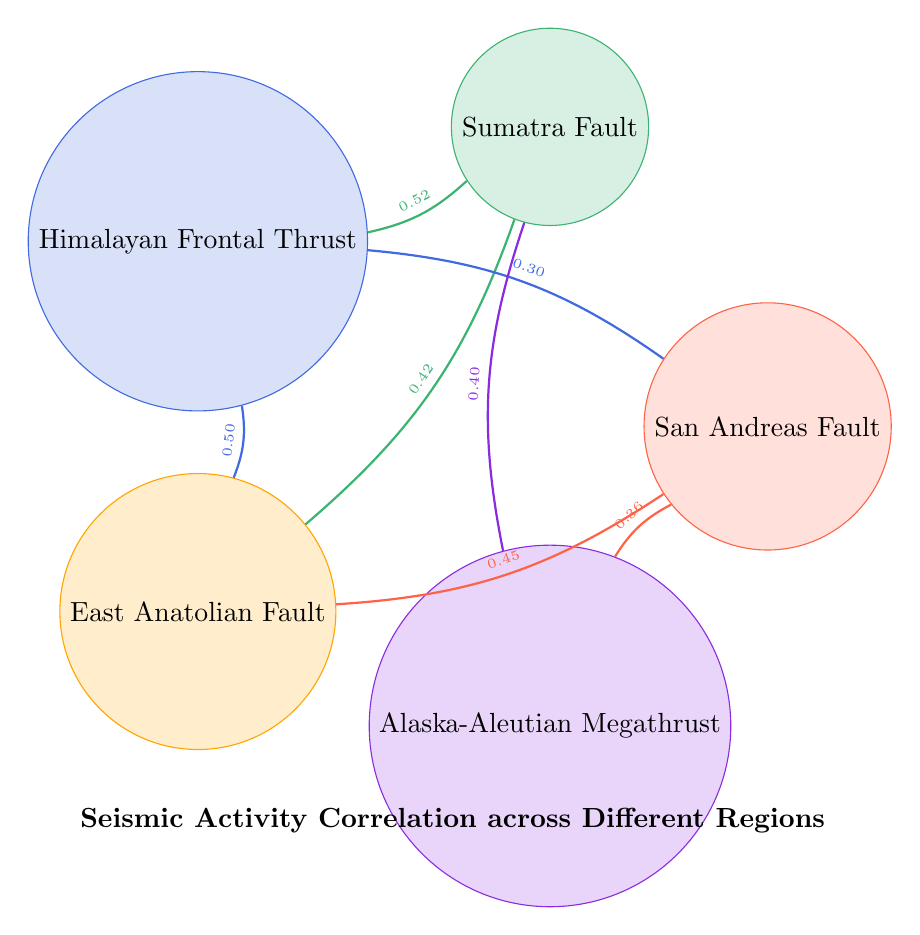What is the highest correlation value present in the diagram? By examining the links between nodes in the chord diagram, the highest correlation value shown is for the link between the Sumatra Fault and the Himalayan Frontal Thrust, which is 0.52.
Answer: 0.52 Which fault has a correlation of 0.40? Looking at the links in the diagram, the correlation of 0.40 is between the Alaska-Aleutian Megathrust and the Sumatra Fault.
Answer: Sumatra Fault How many regions are represented in the diagram? The data shows five distinct nodes, each representing a different fault in a unique region (California, Indonesia, Nepal, Turkey, Alaska), therefore there are 5 regions represented.
Answer: 5 Which two faults have the strongest correlation with a value of 0.50? In the diagram, the correlation of 0.50 exists between the Himalayan Frontal Thrust and the East Anatolian Fault.
Answer: Himalayan Frontal Thrust, East Anatolian Fault Is the correlation between the San Andreas Fault and the Alaska-Aleutian Megathrust greater than 0.35? The correlation between the San Andreas Fault and the Alaska-Aleutian Megathrust is explicitly labeled as 0.36, which is indeed greater than 0.35.
Answer: Yes Which fault has the weakest correlation with the San Andreas Fault? Among the links connected to the San Andreas Fault, the weakest correlation is with the Himalayan Frontal Thrust, which is 0.30.
Answer: 0.30 What is the total number of links depicted in the diagram? The diagram contains six links, indicating the correlation between the various faults mentioned.
Answer: 6 Identify the nodes connected to the Sumatra Fault. The Sumatra Fault has links with the Himalayan Frontal Thrust (0.52), East Anatolian Fault (0.42), and Alaska-Aleutian Megathrust (0.40), which are the nodes connected to it.
Answer: Himalayan Frontal Thrust, East Anatolian Fault, Alaska-Aleutian Megathrust What color represents the East Anatolian Fault? In the diagram, the East Anatolian Fault is represented by the color orange.
Answer: Orange 